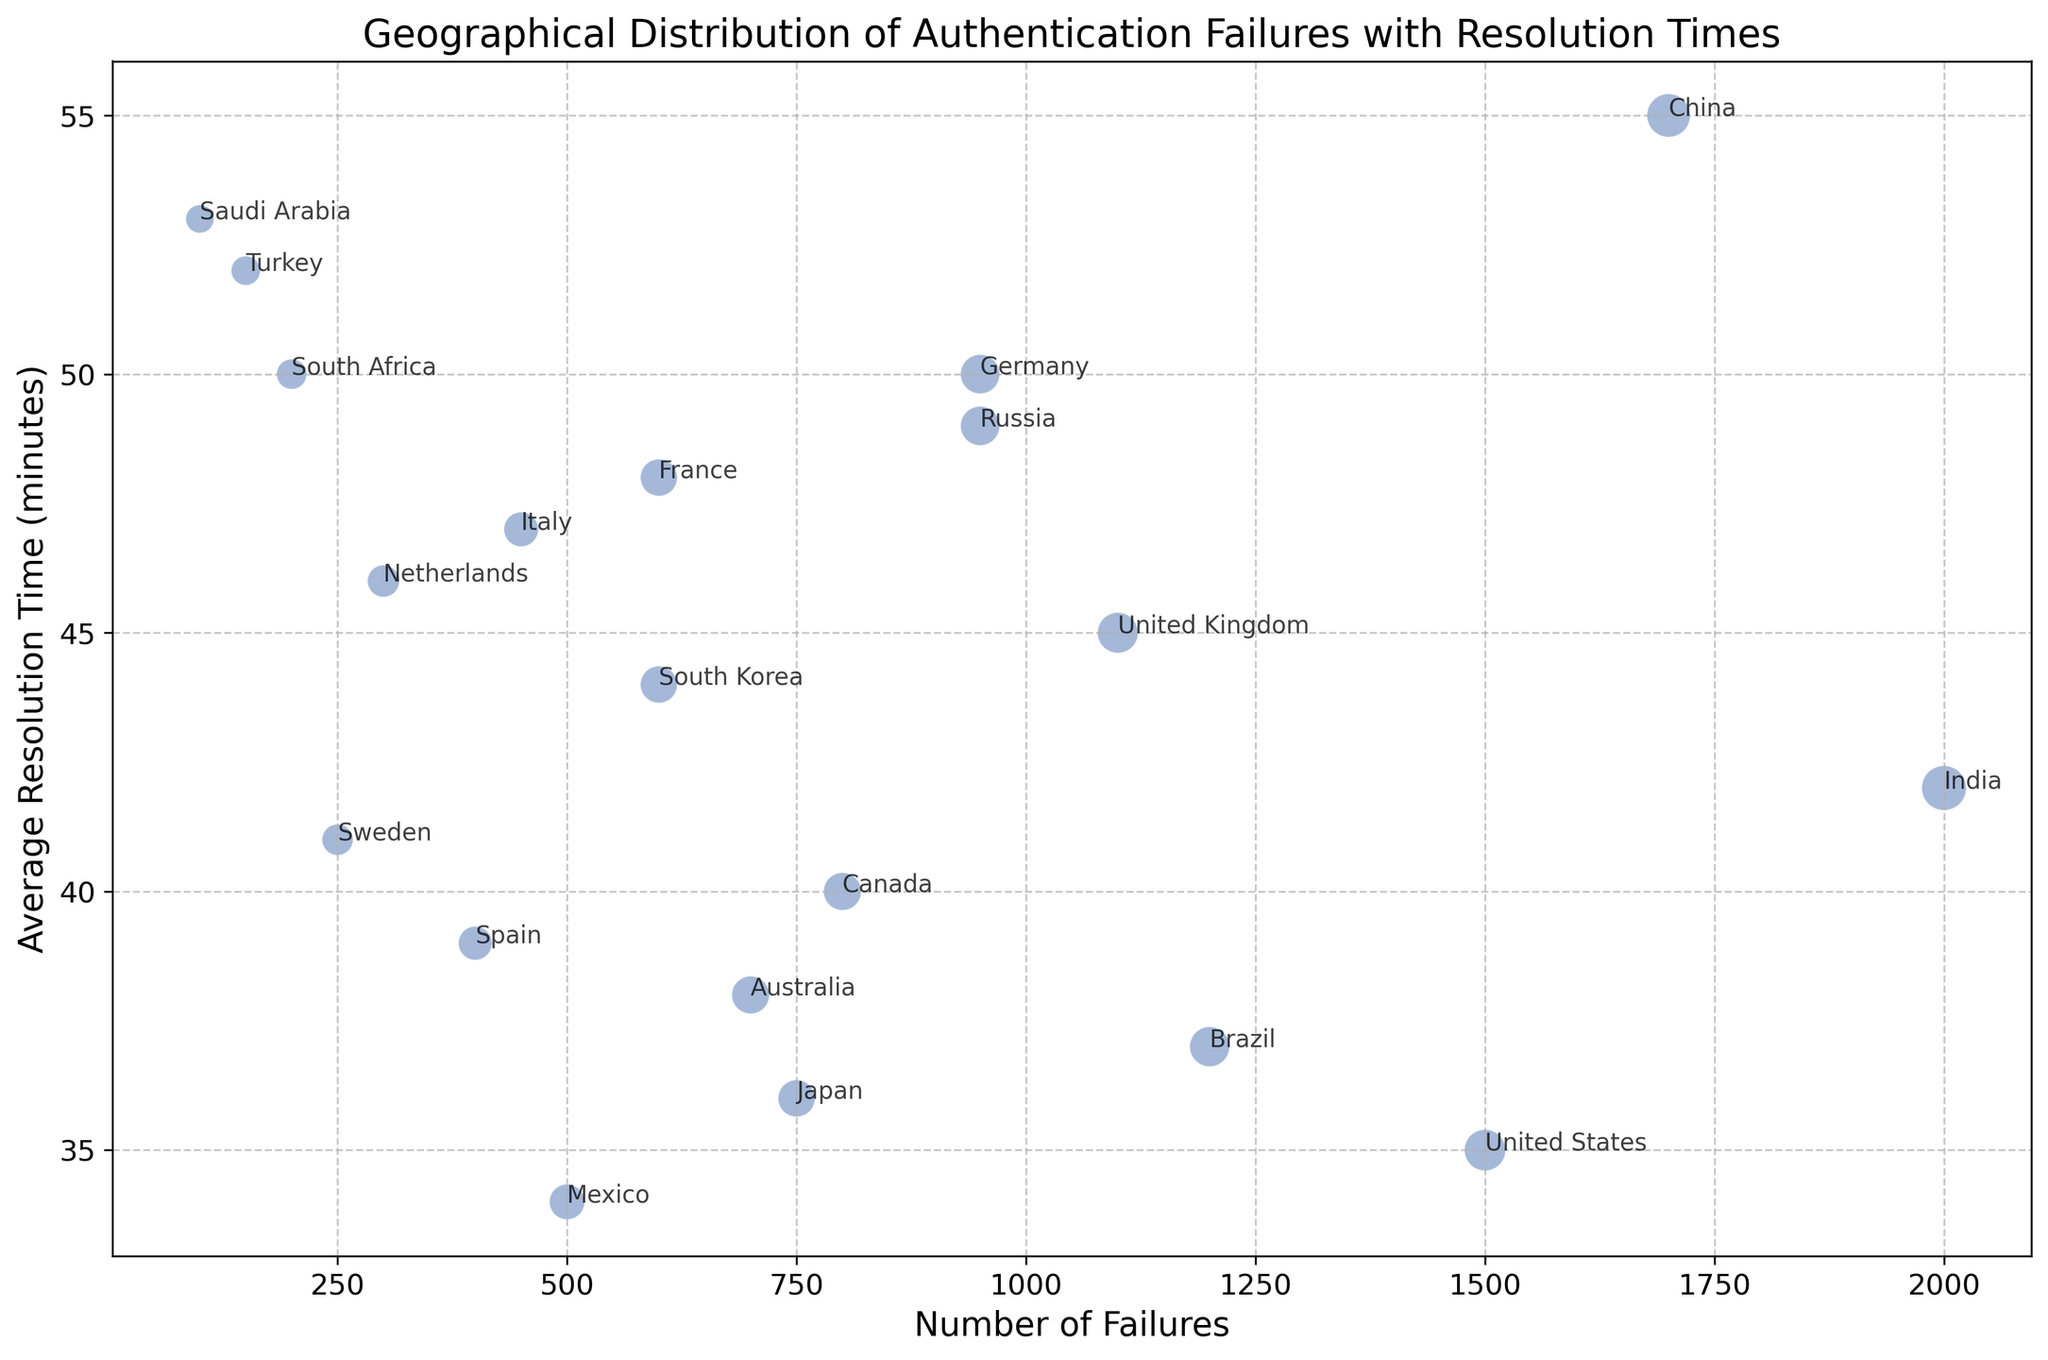Which country has the highest number of authentication failures? The highest point on the x-axis represents the country with the most failures. India is positioned at the farthest right on the chart.
Answer: India Which country has the lowest average resolution time for authentication failures? The lowest point on the y-axis represents the country with the lowest resolution time. Mexico is the lowest on the y-axis at 34 minutes.
Answer: Mexico Which two countries have the same number of failures but different resolution times? Identify overlapping or nearby bubbles on the x-axis but with different y-axis values. Germany and Russia each have 950 failures but differ in resolution times.
Answer: Germany, Russia What is the average resolution time across all countries? Sum all average resolution times and divide by the number of countries. The calculation is (35 + 40 + 50 + 45 + 48 + 38 + 42 + 55 + 37 + 49 + 36 + 34 + 44 + 47 + 39 + 46 + 41 + 50 + 52 + 53) / 20 = 44.5.
Answer: 44.5 Which country has the largest bubble size, indicating the most significant impact? Look for the largest bubble on the chart. India's bubble is the largest.
Answer: India Compare the resolution times between the United States and China. Which country took longer on average to resolve authentication failures? The United States is at 35 minutes and China at 55 minutes on the y-axis. China took longer.
Answer: China What is the combined number of failures for Brazil and Japan? Sum the failures for Brazil (1200) and Japan (750). 1200 + 750 = 1950.
Answer: 1950 Which country has a higher average resolution time: Italy or South Korea? Compare the y-axis positions of Italy and South Korea. Italy is at 47 minutes and South Korea is at 44 minutes. Italy is higher.
Answer: Italy Identify the country with the smallest number of failures. How quickly do they resolve issues on average? The lowest point on the x-axis indicates the country with the fewest failures. Saudi Arabia has 100 failures and resolves them in 53 minutes.
Answer: Saudi Arabia, 53 minutes 